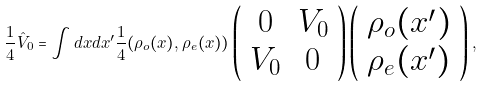Convert formula to latex. <formula><loc_0><loc_0><loc_500><loc_500>\frac { 1 } { 4 } \hat { V } _ { 0 } = \int d x d x ^ { \prime } \frac { 1 } { 4 } ( \rho _ { o } ( x ) , \rho _ { e } ( x ) ) \left ( \begin{array} { c c } 0 & V _ { 0 } \\ V _ { 0 } & 0 \end{array} \right ) \left ( \begin{array} { l } \rho _ { o } ( x ^ { \prime } ) \\ \rho _ { e } ( x ^ { \prime } ) \end{array} \right ) ,</formula> 